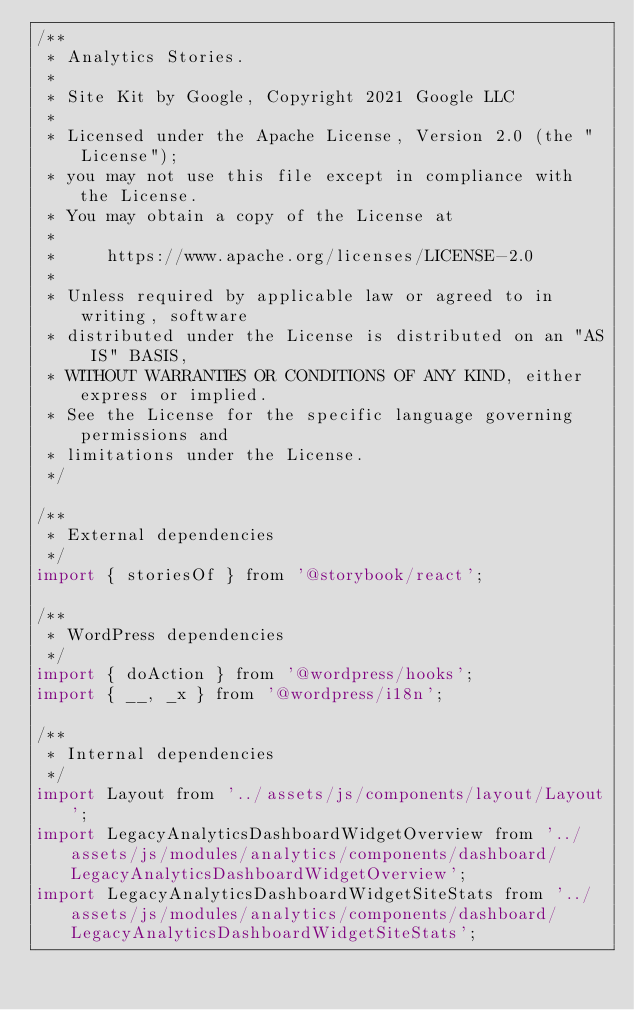Convert code to text. <code><loc_0><loc_0><loc_500><loc_500><_JavaScript_>/**
 * Analytics Stories.
 *
 * Site Kit by Google, Copyright 2021 Google LLC
 *
 * Licensed under the Apache License, Version 2.0 (the "License");
 * you may not use this file except in compliance with the License.
 * You may obtain a copy of the License at
 *
 *     https://www.apache.org/licenses/LICENSE-2.0
 *
 * Unless required by applicable law or agreed to in writing, software
 * distributed under the License is distributed on an "AS IS" BASIS,
 * WITHOUT WARRANTIES OR CONDITIONS OF ANY KIND, either express or implied.
 * See the License for the specific language governing permissions and
 * limitations under the License.
 */

/**
 * External dependencies
 */
import { storiesOf } from '@storybook/react';

/**
 * WordPress dependencies
 */
import { doAction } from '@wordpress/hooks';
import { __, _x } from '@wordpress/i18n';

/**
 * Internal dependencies
 */
import Layout from '../assets/js/components/layout/Layout';
import LegacyAnalyticsDashboardWidgetOverview from '../assets/js/modules/analytics/components/dashboard/LegacyAnalyticsDashboardWidgetOverview';
import LegacyAnalyticsDashboardWidgetSiteStats from '../assets/js/modules/analytics/components/dashboard/LegacyAnalyticsDashboardWidgetSiteStats';</code> 